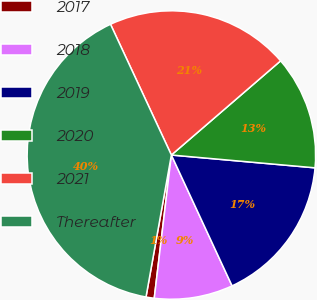<chart> <loc_0><loc_0><loc_500><loc_500><pie_chart><fcel>2017<fcel>2018<fcel>2019<fcel>2020<fcel>2021<fcel>Thereafter<nl><fcel>0.92%<fcel>8.81%<fcel>16.67%<fcel>12.74%<fcel>20.61%<fcel>40.25%<nl></chart> 